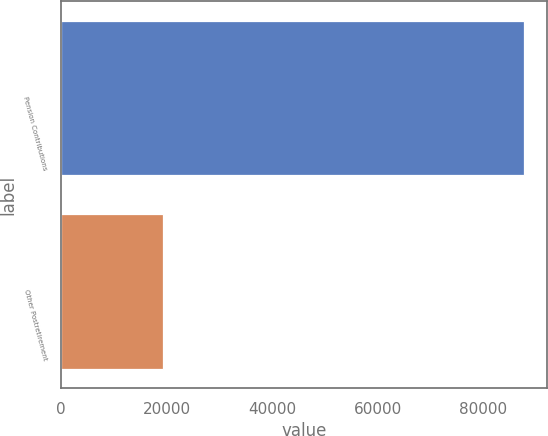Convert chart. <chart><loc_0><loc_0><loc_500><loc_500><bar_chart><fcel>Pension Contributions<fcel>Other Postretirement<nl><fcel>87702<fcel>19284<nl></chart> 